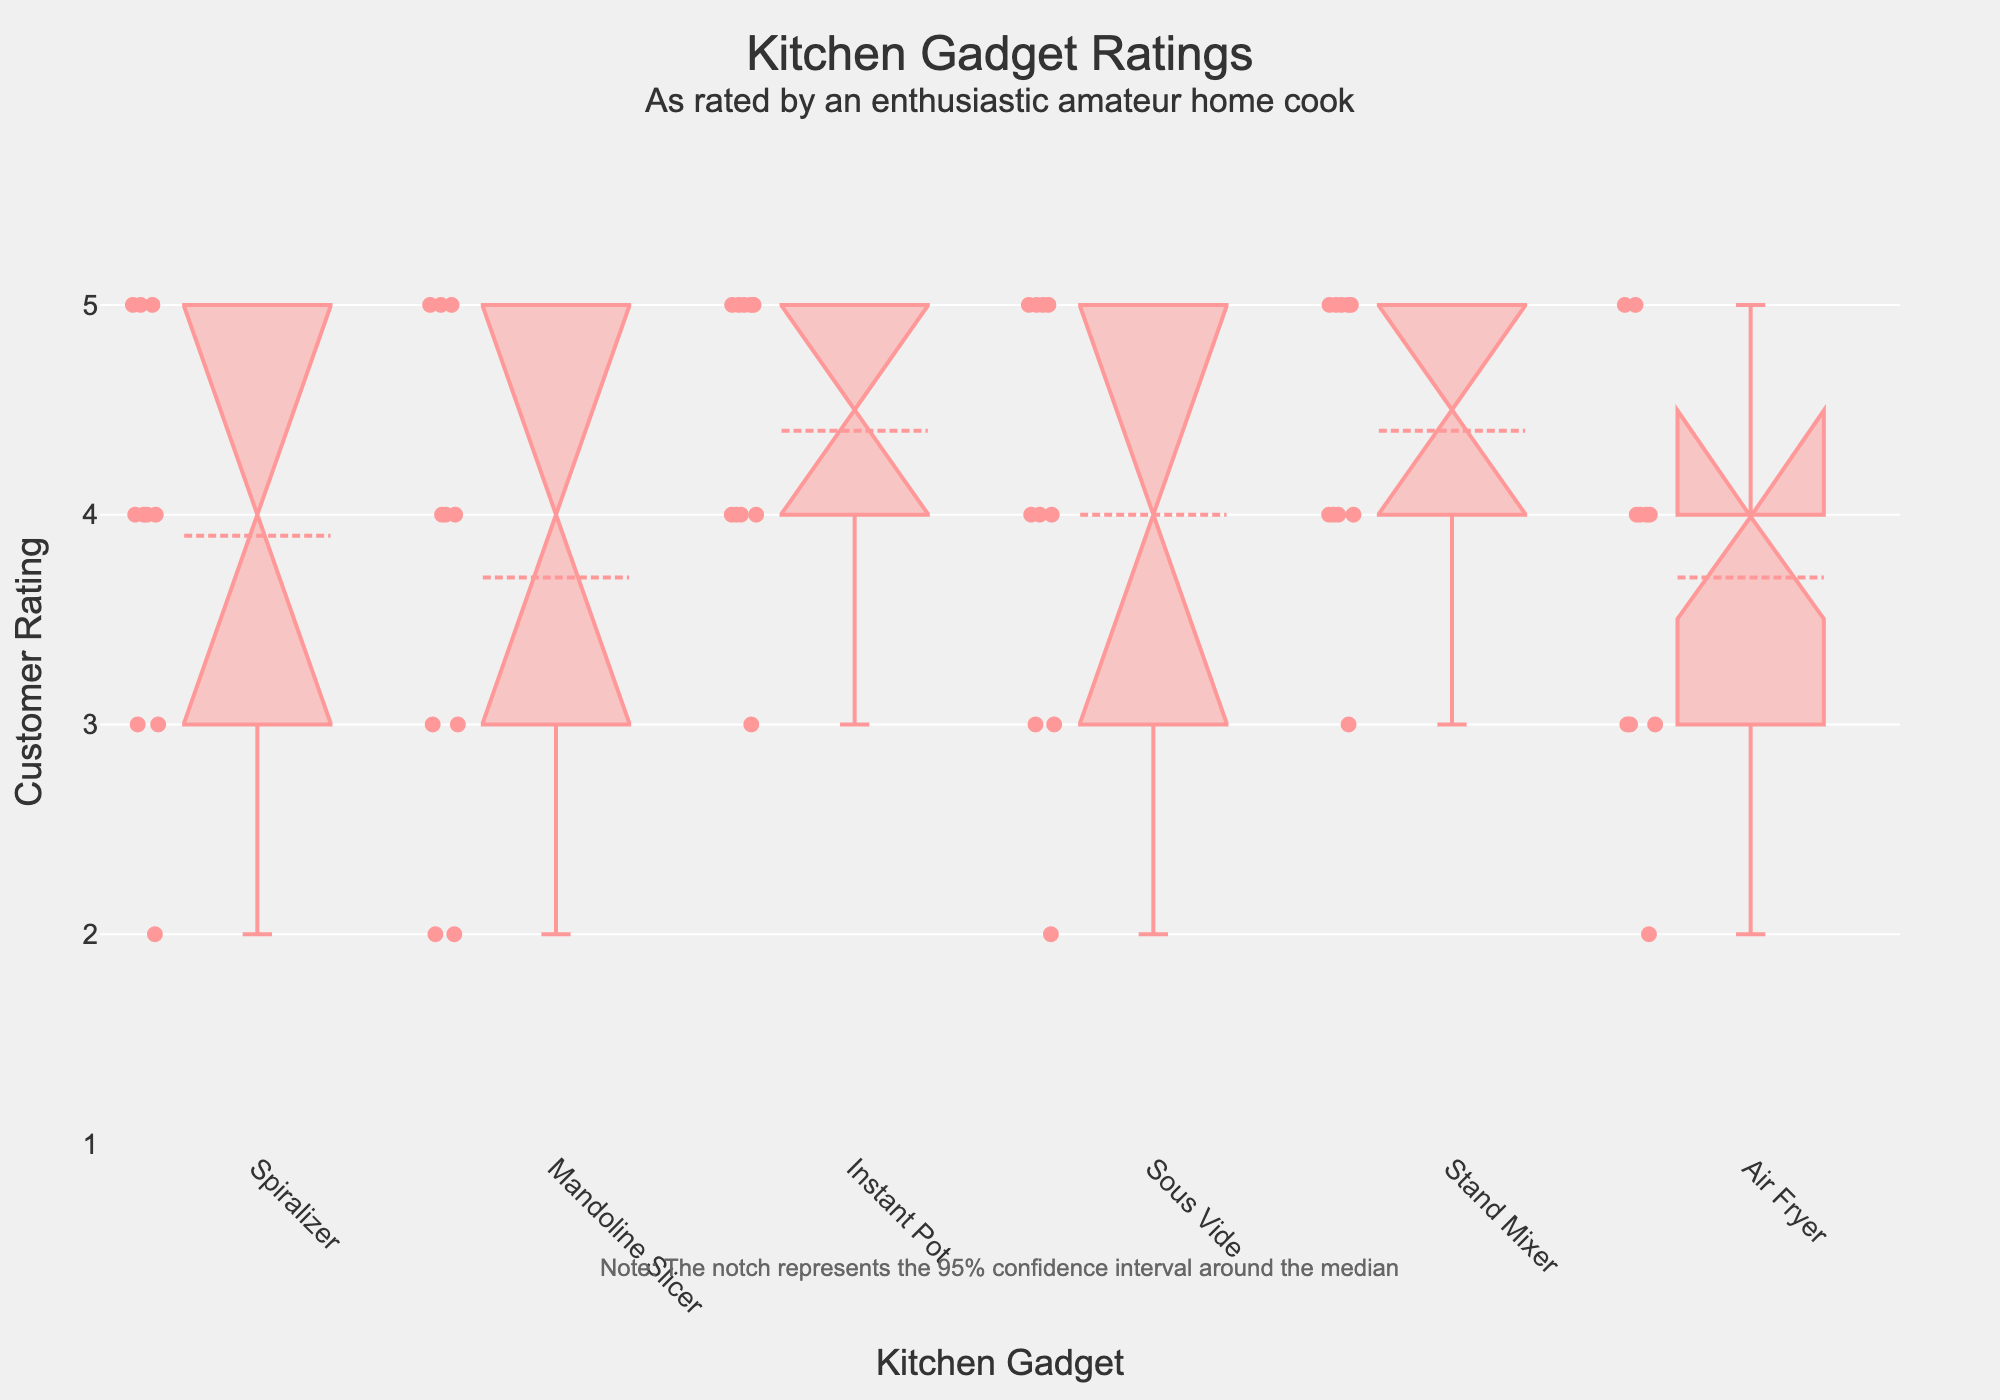What is the title of the chart? The title of the chart is typically displayed at the top of the figure. It helps understand what the entire plot is about. In this case, it mentions "Kitchen Gadget Ratings" and specifies these ratings are from an enthusiastic amateur home cook.
Answer: Kitchen Gadget Ratings Which kitchen gadget has the widest spread of customer ratings? To determine the widest spread of customer ratings, look for the box with the longest vertical extent (from the bottom whisker to the top whisker). This box will have ratings spanning the widest range.
Answer: Mandoline Slicer What is the median rating for the Stand Mixer? The median rating is represented by the central line inside the notch of the box. Locate the Stand Mixer box and find the value of the line within the notch.
Answer: 4.5 Which kitchen gadget has the highest median rating? The highest median rating is indicated by the median line's position within the notch. Compare the median lines across all gadgets to find the highest one.
Answer: Stand Mixer How many data points are there for the Air Fryer? Each box plot shows individual points as dots around the box. Count the number of dots present for the Air Fryer box plot.
Answer: 10 Which gadgets have an outlier in their ratings? Outliers are points that fall outside the whiskers of the box plot. Check each gadget's box plot for any points that lie beyond the whiskers.
Answer: Spiralizer, Mandoline Slicer, Sous Vide, Air Fryer What is the interquartile range (IQR) for the Instant Pot's ratings? The IQR is the range between the first quartile (Q1) and the third quartile (Q3) of a box plot. Identify the top and bottom of the box for the Instant Pot, and subtract the value at the bottom (Q1) from the value at the top (Q3).
Answer: 1 How do the ratings of the Sous Vide compare to the Spiralizer? Compare the central tendency (median), variability (IQR), and spread (whiskers) of the ratings for both gadgets. Look at the median positions, box extents, and whisker lengths for both gadgets.
Answer: The Sous Vide generally has slightly higher ratings and a narrower interquartile range compared to the Spiralizer Which gadget has the smallest notch indicating a narrow confidence interval around the median? The size of the notch indicates the confidence interval around the median. Find the box plot with the smallest vertical notch.
Answer: Stand Mixer Are there any gadgets where the median rating is exactly 4? Look at the median line within the notch for a value precisely at 4.
Answer: Spiralizer, Instant Pot 